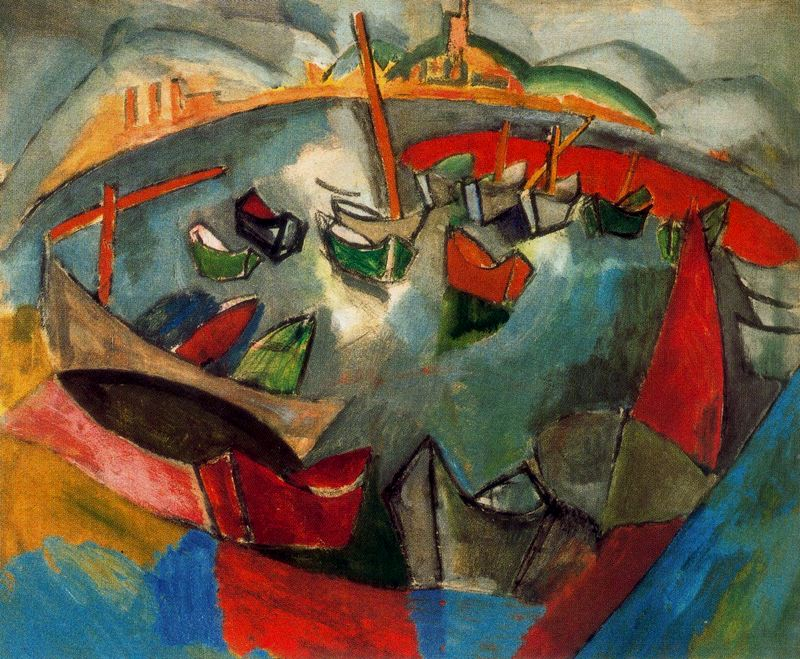Can you tell me more about the style of painting seen here? Certainly! The painting is rendered in a post-impressionist style, characterized by vibrant colors and bold, visible brushstrokes that defy the conventions of precise realism. This style often seeks to convey the artist's emotional response to a scene rather than a detailed, literal representation. 